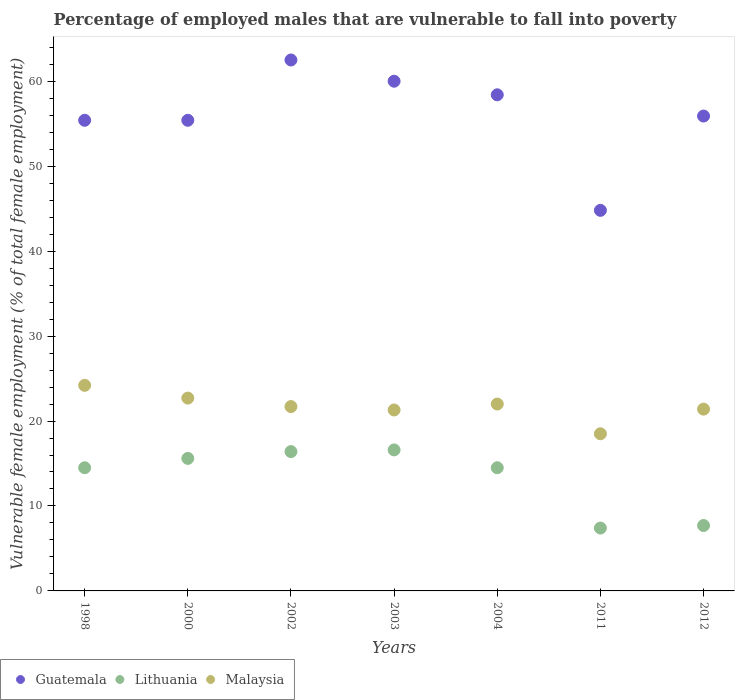Is the number of dotlines equal to the number of legend labels?
Provide a short and direct response. Yes. What is the percentage of employed males who are vulnerable to fall into poverty in Malaysia in 2004?
Ensure brevity in your answer.  22. Across all years, what is the maximum percentage of employed males who are vulnerable to fall into poverty in Guatemala?
Provide a short and direct response. 62.5. Across all years, what is the minimum percentage of employed males who are vulnerable to fall into poverty in Lithuania?
Give a very brief answer. 7.4. In which year was the percentage of employed males who are vulnerable to fall into poverty in Guatemala maximum?
Provide a succinct answer. 2002. What is the total percentage of employed males who are vulnerable to fall into poverty in Malaysia in the graph?
Make the answer very short. 151.8. What is the difference between the percentage of employed males who are vulnerable to fall into poverty in Guatemala in 2000 and that in 2003?
Keep it short and to the point. -4.6. What is the difference between the percentage of employed males who are vulnerable to fall into poverty in Guatemala in 2011 and the percentage of employed males who are vulnerable to fall into poverty in Lithuania in 2003?
Give a very brief answer. 28.2. What is the average percentage of employed males who are vulnerable to fall into poverty in Lithuania per year?
Give a very brief answer. 13.24. In the year 2002, what is the difference between the percentage of employed males who are vulnerable to fall into poverty in Malaysia and percentage of employed males who are vulnerable to fall into poverty in Guatemala?
Keep it short and to the point. -40.8. What is the ratio of the percentage of employed males who are vulnerable to fall into poverty in Malaysia in 2004 to that in 2011?
Your response must be concise. 1.19. Is the percentage of employed males who are vulnerable to fall into poverty in Lithuania in 1998 less than that in 2003?
Offer a very short reply. Yes. What is the difference between the highest and the second highest percentage of employed males who are vulnerable to fall into poverty in Malaysia?
Make the answer very short. 1.5. What is the difference between the highest and the lowest percentage of employed males who are vulnerable to fall into poverty in Malaysia?
Your response must be concise. 5.7. Is the sum of the percentage of employed males who are vulnerable to fall into poverty in Lithuania in 2003 and 2011 greater than the maximum percentage of employed males who are vulnerable to fall into poverty in Guatemala across all years?
Make the answer very short. No. Is the percentage of employed males who are vulnerable to fall into poverty in Lithuania strictly greater than the percentage of employed males who are vulnerable to fall into poverty in Guatemala over the years?
Give a very brief answer. No. How many years are there in the graph?
Provide a succinct answer. 7. Where does the legend appear in the graph?
Your answer should be very brief. Bottom left. How many legend labels are there?
Provide a short and direct response. 3. How are the legend labels stacked?
Your answer should be compact. Horizontal. What is the title of the graph?
Your answer should be very brief. Percentage of employed males that are vulnerable to fall into poverty. What is the label or title of the X-axis?
Offer a very short reply. Years. What is the label or title of the Y-axis?
Make the answer very short. Vulnerable female employment (% of total female employment). What is the Vulnerable female employment (% of total female employment) of Guatemala in 1998?
Provide a short and direct response. 55.4. What is the Vulnerable female employment (% of total female employment) in Malaysia in 1998?
Make the answer very short. 24.2. What is the Vulnerable female employment (% of total female employment) of Guatemala in 2000?
Provide a short and direct response. 55.4. What is the Vulnerable female employment (% of total female employment) in Lithuania in 2000?
Your answer should be compact. 15.6. What is the Vulnerable female employment (% of total female employment) of Malaysia in 2000?
Your answer should be very brief. 22.7. What is the Vulnerable female employment (% of total female employment) of Guatemala in 2002?
Give a very brief answer. 62.5. What is the Vulnerable female employment (% of total female employment) of Lithuania in 2002?
Your response must be concise. 16.4. What is the Vulnerable female employment (% of total female employment) in Malaysia in 2002?
Give a very brief answer. 21.7. What is the Vulnerable female employment (% of total female employment) of Lithuania in 2003?
Provide a succinct answer. 16.6. What is the Vulnerable female employment (% of total female employment) of Malaysia in 2003?
Your answer should be compact. 21.3. What is the Vulnerable female employment (% of total female employment) of Guatemala in 2004?
Keep it short and to the point. 58.4. What is the Vulnerable female employment (% of total female employment) in Malaysia in 2004?
Your answer should be very brief. 22. What is the Vulnerable female employment (% of total female employment) in Guatemala in 2011?
Offer a very short reply. 44.8. What is the Vulnerable female employment (% of total female employment) in Lithuania in 2011?
Ensure brevity in your answer.  7.4. What is the Vulnerable female employment (% of total female employment) of Guatemala in 2012?
Give a very brief answer. 55.9. What is the Vulnerable female employment (% of total female employment) of Lithuania in 2012?
Provide a short and direct response. 7.7. What is the Vulnerable female employment (% of total female employment) in Malaysia in 2012?
Ensure brevity in your answer.  21.4. Across all years, what is the maximum Vulnerable female employment (% of total female employment) in Guatemala?
Offer a very short reply. 62.5. Across all years, what is the maximum Vulnerable female employment (% of total female employment) of Lithuania?
Give a very brief answer. 16.6. Across all years, what is the maximum Vulnerable female employment (% of total female employment) in Malaysia?
Give a very brief answer. 24.2. Across all years, what is the minimum Vulnerable female employment (% of total female employment) of Guatemala?
Offer a very short reply. 44.8. Across all years, what is the minimum Vulnerable female employment (% of total female employment) of Lithuania?
Provide a short and direct response. 7.4. What is the total Vulnerable female employment (% of total female employment) of Guatemala in the graph?
Your answer should be very brief. 392.4. What is the total Vulnerable female employment (% of total female employment) in Lithuania in the graph?
Keep it short and to the point. 92.7. What is the total Vulnerable female employment (% of total female employment) in Malaysia in the graph?
Ensure brevity in your answer.  151.8. What is the difference between the Vulnerable female employment (% of total female employment) in Lithuania in 1998 and that in 2000?
Offer a very short reply. -1.1. What is the difference between the Vulnerable female employment (% of total female employment) of Malaysia in 1998 and that in 2000?
Your response must be concise. 1.5. What is the difference between the Vulnerable female employment (% of total female employment) of Guatemala in 1998 and that in 2002?
Make the answer very short. -7.1. What is the difference between the Vulnerable female employment (% of total female employment) of Lithuania in 1998 and that in 2002?
Provide a short and direct response. -1.9. What is the difference between the Vulnerable female employment (% of total female employment) of Malaysia in 1998 and that in 2002?
Your answer should be very brief. 2.5. What is the difference between the Vulnerable female employment (% of total female employment) of Guatemala in 1998 and that in 2003?
Your response must be concise. -4.6. What is the difference between the Vulnerable female employment (% of total female employment) of Malaysia in 1998 and that in 2003?
Provide a short and direct response. 2.9. What is the difference between the Vulnerable female employment (% of total female employment) of Guatemala in 1998 and that in 2004?
Provide a short and direct response. -3. What is the difference between the Vulnerable female employment (% of total female employment) in Guatemala in 1998 and that in 2011?
Provide a short and direct response. 10.6. What is the difference between the Vulnerable female employment (% of total female employment) in Malaysia in 1998 and that in 2011?
Your answer should be very brief. 5.7. What is the difference between the Vulnerable female employment (% of total female employment) in Guatemala in 2000 and that in 2002?
Ensure brevity in your answer.  -7.1. What is the difference between the Vulnerable female employment (% of total female employment) of Lithuania in 2000 and that in 2002?
Give a very brief answer. -0.8. What is the difference between the Vulnerable female employment (% of total female employment) of Malaysia in 2000 and that in 2002?
Offer a terse response. 1. What is the difference between the Vulnerable female employment (% of total female employment) of Lithuania in 2000 and that in 2003?
Keep it short and to the point. -1. What is the difference between the Vulnerable female employment (% of total female employment) of Guatemala in 2000 and that in 2004?
Provide a succinct answer. -3. What is the difference between the Vulnerable female employment (% of total female employment) of Lithuania in 2000 and that in 2004?
Offer a terse response. 1.1. What is the difference between the Vulnerable female employment (% of total female employment) in Guatemala in 2000 and that in 2012?
Your answer should be very brief. -0.5. What is the difference between the Vulnerable female employment (% of total female employment) in Lithuania in 2000 and that in 2012?
Your answer should be very brief. 7.9. What is the difference between the Vulnerable female employment (% of total female employment) of Malaysia in 2000 and that in 2012?
Ensure brevity in your answer.  1.3. What is the difference between the Vulnerable female employment (% of total female employment) in Guatemala in 2002 and that in 2003?
Keep it short and to the point. 2.5. What is the difference between the Vulnerable female employment (% of total female employment) of Guatemala in 2002 and that in 2004?
Give a very brief answer. 4.1. What is the difference between the Vulnerable female employment (% of total female employment) of Malaysia in 2002 and that in 2004?
Make the answer very short. -0.3. What is the difference between the Vulnerable female employment (% of total female employment) in Guatemala in 2002 and that in 2011?
Ensure brevity in your answer.  17.7. What is the difference between the Vulnerable female employment (% of total female employment) in Guatemala in 2002 and that in 2012?
Your answer should be compact. 6.6. What is the difference between the Vulnerable female employment (% of total female employment) of Lithuania in 2002 and that in 2012?
Give a very brief answer. 8.7. What is the difference between the Vulnerable female employment (% of total female employment) in Lithuania in 2003 and that in 2004?
Offer a very short reply. 2.1. What is the difference between the Vulnerable female employment (% of total female employment) in Malaysia in 2003 and that in 2004?
Make the answer very short. -0.7. What is the difference between the Vulnerable female employment (% of total female employment) of Lithuania in 2003 and that in 2011?
Give a very brief answer. 9.2. What is the difference between the Vulnerable female employment (% of total female employment) in Malaysia in 2003 and that in 2011?
Your response must be concise. 2.8. What is the difference between the Vulnerable female employment (% of total female employment) of Lithuania in 2003 and that in 2012?
Provide a succinct answer. 8.9. What is the difference between the Vulnerable female employment (% of total female employment) of Malaysia in 2003 and that in 2012?
Offer a terse response. -0.1. What is the difference between the Vulnerable female employment (% of total female employment) in Lithuania in 2004 and that in 2011?
Ensure brevity in your answer.  7.1. What is the difference between the Vulnerable female employment (% of total female employment) in Malaysia in 2004 and that in 2011?
Ensure brevity in your answer.  3.5. What is the difference between the Vulnerable female employment (% of total female employment) of Malaysia in 2004 and that in 2012?
Give a very brief answer. 0.6. What is the difference between the Vulnerable female employment (% of total female employment) of Lithuania in 2011 and that in 2012?
Ensure brevity in your answer.  -0.3. What is the difference between the Vulnerable female employment (% of total female employment) of Guatemala in 1998 and the Vulnerable female employment (% of total female employment) of Lithuania in 2000?
Your answer should be very brief. 39.8. What is the difference between the Vulnerable female employment (% of total female employment) of Guatemala in 1998 and the Vulnerable female employment (% of total female employment) of Malaysia in 2000?
Ensure brevity in your answer.  32.7. What is the difference between the Vulnerable female employment (% of total female employment) in Guatemala in 1998 and the Vulnerable female employment (% of total female employment) in Lithuania in 2002?
Offer a terse response. 39. What is the difference between the Vulnerable female employment (% of total female employment) of Guatemala in 1998 and the Vulnerable female employment (% of total female employment) of Malaysia in 2002?
Your answer should be compact. 33.7. What is the difference between the Vulnerable female employment (% of total female employment) of Lithuania in 1998 and the Vulnerable female employment (% of total female employment) of Malaysia in 2002?
Give a very brief answer. -7.2. What is the difference between the Vulnerable female employment (% of total female employment) of Guatemala in 1998 and the Vulnerable female employment (% of total female employment) of Lithuania in 2003?
Give a very brief answer. 38.8. What is the difference between the Vulnerable female employment (% of total female employment) in Guatemala in 1998 and the Vulnerable female employment (% of total female employment) in Malaysia in 2003?
Your response must be concise. 34.1. What is the difference between the Vulnerable female employment (% of total female employment) of Guatemala in 1998 and the Vulnerable female employment (% of total female employment) of Lithuania in 2004?
Provide a succinct answer. 40.9. What is the difference between the Vulnerable female employment (% of total female employment) in Guatemala in 1998 and the Vulnerable female employment (% of total female employment) in Malaysia in 2004?
Provide a short and direct response. 33.4. What is the difference between the Vulnerable female employment (% of total female employment) in Lithuania in 1998 and the Vulnerable female employment (% of total female employment) in Malaysia in 2004?
Provide a short and direct response. -7.5. What is the difference between the Vulnerable female employment (% of total female employment) in Guatemala in 1998 and the Vulnerable female employment (% of total female employment) in Lithuania in 2011?
Make the answer very short. 48. What is the difference between the Vulnerable female employment (% of total female employment) of Guatemala in 1998 and the Vulnerable female employment (% of total female employment) of Malaysia in 2011?
Make the answer very short. 36.9. What is the difference between the Vulnerable female employment (% of total female employment) in Lithuania in 1998 and the Vulnerable female employment (% of total female employment) in Malaysia in 2011?
Give a very brief answer. -4. What is the difference between the Vulnerable female employment (% of total female employment) of Guatemala in 1998 and the Vulnerable female employment (% of total female employment) of Lithuania in 2012?
Give a very brief answer. 47.7. What is the difference between the Vulnerable female employment (% of total female employment) of Guatemala in 1998 and the Vulnerable female employment (% of total female employment) of Malaysia in 2012?
Your answer should be compact. 34. What is the difference between the Vulnerable female employment (% of total female employment) in Guatemala in 2000 and the Vulnerable female employment (% of total female employment) in Lithuania in 2002?
Keep it short and to the point. 39. What is the difference between the Vulnerable female employment (% of total female employment) of Guatemala in 2000 and the Vulnerable female employment (% of total female employment) of Malaysia in 2002?
Your answer should be very brief. 33.7. What is the difference between the Vulnerable female employment (% of total female employment) in Guatemala in 2000 and the Vulnerable female employment (% of total female employment) in Lithuania in 2003?
Offer a terse response. 38.8. What is the difference between the Vulnerable female employment (% of total female employment) of Guatemala in 2000 and the Vulnerable female employment (% of total female employment) of Malaysia in 2003?
Make the answer very short. 34.1. What is the difference between the Vulnerable female employment (% of total female employment) in Guatemala in 2000 and the Vulnerable female employment (% of total female employment) in Lithuania in 2004?
Your answer should be very brief. 40.9. What is the difference between the Vulnerable female employment (% of total female employment) in Guatemala in 2000 and the Vulnerable female employment (% of total female employment) in Malaysia in 2004?
Keep it short and to the point. 33.4. What is the difference between the Vulnerable female employment (% of total female employment) of Lithuania in 2000 and the Vulnerable female employment (% of total female employment) of Malaysia in 2004?
Your response must be concise. -6.4. What is the difference between the Vulnerable female employment (% of total female employment) in Guatemala in 2000 and the Vulnerable female employment (% of total female employment) in Lithuania in 2011?
Ensure brevity in your answer.  48. What is the difference between the Vulnerable female employment (% of total female employment) in Guatemala in 2000 and the Vulnerable female employment (% of total female employment) in Malaysia in 2011?
Make the answer very short. 36.9. What is the difference between the Vulnerable female employment (% of total female employment) in Lithuania in 2000 and the Vulnerable female employment (% of total female employment) in Malaysia in 2011?
Provide a short and direct response. -2.9. What is the difference between the Vulnerable female employment (% of total female employment) in Guatemala in 2000 and the Vulnerable female employment (% of total female employment) in Lithuania in 2012?
Provide a succinct answer. 47.7. What is the difference between the Vulnerable female employment (% of total female employment) in Guatemala in 2002 and the Vulnerable female employment (% of total female employment) in Lithuania in 2003?
Your answer should be compact. 45.9. What is the difference between the Vulnerable female employment (% of total female employment) of Guatemala in 2002 and the Vulnerable female employment (% of total female employment) of Malaysia in 2003?
Provide a short and direct response. 41.2. What is the difference between the Vulnerable female employment (% of total female employment) in Guatemala in 2002 and the Vulnerable female employment (% of total female employment) in Malaysia in 2004?
Ensure brevity in your answer.  40.5. What is the difference between the Vulnerable female employment (% of total female employment) in Guatemala in 2002 and the Vulnerable female employment (% of total female employment) in Lithuania in 2011?
Your answer should be very brief. 55.1. What is the difference between the Vulnerable female employment (% of total female employment) of Guatemala in 2002 and the Vulnerable female employment (% of total female employment) of Malaysia in 2011?
Your answer should be very brief. 44. What is the difference between the Vulnerable female employment (% of total female employment) of Lithuania in 2002 and the Vulnerable female employment (% of total female employment) of Malaysia in 2011?
Give a very brief answer. -2.1. What is the difference between the Vulnerable female employment (% of total female employment) of Guatemala in 2002 and the Vulnerable female employment (% of total female employment) of Lithuania in 2012?
Your answer should be compact. 54.8. What is the difference between the Vulnerable female employment (% of total female employment) in Guatemala in 2002 and the Vulnerable female employment (% of total female employment) in Malaysia in 2012?
Offer a very short reply. 41.1. What is the difference between the Vulnerable female employment (% of total female employment) of Guatemala in 2003 and the Vulnerable female employment (% of total female employment) of Lithuania in 2004?
Your answer should be compact. 45.5. What is the difference between the Vulnerable female employment (% of total female employment) of Guatemala in 2003 and the Vulnerable female employment (% of total female employment) of Malaysia in 2004?
Give a very brief answer. 38. What is the difference between the Vulnerable female employment (% of total female employment) of Lithuania in 2003 and the Vulnerable female employment (% of total female employment) of Malaysia in 2004?
Provide a short and direct response. -5.4. What is the difference between the Vulnerable female employment (% of total female employment) of Guatemala in 2003 and the Vulnerable female employment (% of total female employment) of Lithuania in 2011?
Your answer should be very brief. 52.6. What is the difference between the Vulnerable female employment (% of total female employment) in Guatemala in 2003 and the Vulnerable female employment (% of total female employment) in Malaysia in 2011?
Your answer should be very brief. 41.5. What is the difference between the Vulnerable female employment (% of total female employment) in Lithuania in 2003 and the Vulnerable female employment (% of total female employment) in Malaysia in 2011?
Keep it short and to the point. -1.9. What is the difference between the Vulnerable female employment (% of total female employment) of Guatemala in 2003 and the Vulnerable female employment (% of total female employment) of Lithuania in 2012?
Give a very brief answer. 52.3. What is the difference between the Vulnerable female employment (% of total female employment) in Guatemala in 2003 and the Vulnerable female employment (% of total female employment) in Malaysia in 2012?
Your answer should be compact. 38.6. What is the difference between the Vulnerable female employment (% of total female employment) of Lithuania in 2003 and the Vulnerable female employment (% of total female employment) of Malaysia in 2012?
Provide a short and direct response. -4.8. What is the difference between the Vulnerable female employment (% of total female employment) in Guatemala in 2004 and the Vulnerable female employment (% of total female employment) in Malaysia in 2011?
Offer a very short reply. 39.9. What is the difference between the Vulnerable female employment (% of total female employment) of Lithuania in 2004 and the Vulnerable female employment (% of total female employment) of Malaysia in 2011?
Ensure brevity in your answer.  -4. What is the difference between the Vulnerable female employment (% of total female employment) of Guatemala in 2004 and the Vulnerable female employment (% of total female employment) of Lithuania in 2012?
Your answer should be compact. 50.7. What is the difference between the Vulnerable female employment (% of total female employment) in Guatemala in 2004 and the Vulnerable female employment (% of total female employment) in Malaysia in 2012?
Ensure brevity in your answer.  37. What is the difference between the Vulnerable female employment (% of total female employment) in Lithuania in 2004 and the Vulnerable female employment (% of total female employment) in Malaysia in 2012?
Your answer should be very brief. -6.9. What is the difference between the Vulnerable female employment (% of total female employment) of Guatemala in 2011 and the Vulnerable female employment (% of total female employment) of Lithuania in 2012?
Your answer should be very brief. 37.1. What is the difference between the Vulnerable female employment (% of total female employment) of Guatemala in 2011 and the Vulnerable female employment (% of total female employment) of Malaysia in 2012?
Give a very brief answer. 23.4. What is the difference between the Vulnerable female employment (% of total female employment) of Lithuania in 2011 and the Vulnerable female employment (% of total female employment) of Malaysia in 2012?
Provide a succinct answer. -14. What is the average Vulnerable female employment (% of total female employment) in Guatemala per year?
Offer a terse response. 56.06. What is the average Vulnerable female employment (% of total female employment) of Lithuania per year?
Your answer should be compact. 13.24. What is the average Vulnerable female employment (% of total female employment) in Malaysia per year?
Your answer should be very brief. 21.69. In the year 1998, what is the difference between the Vulnerable female employment (% of total female employment) in Guatemala and Vulnerable female employment (% of total female employment) in Lithuania?
Offer a terse response. 40.9. In the year 1998, what is the difference between the Vulnerable female employment (% of total female employment) in Guatemala and Vulnerable female employment (% of total female employment) in Malaysia?
Make the answer very short. 31.2. In the year 1998, what is the difference between the Vulnerable female employment (% of total female employment) of Lithuania and Vulnerable female employment (% of total female employment) of Malaysia?
Give a very brief answer. -9.7. In the year 2000, what is the difference between the Vulnerable female employment (% of total female employment) of Guatemala and Vulnerable female employment (% of total female employment) of Lithuania?
Your response must be concise. 39.8. In the year 2000, what is the difference between the Vulnerable female employment (% of total female employment) of Guatemala and Vulnerable female employment (% of total female employment) of Malaysia?
Provide a short and direct response. 32.7. In the year 2000, what is the difference between the Vulnerable female employment (% of total female employment) of Lithuania and Vulnerable female employment (% of total female employment) of Malaysia?
Offer a very short reply. -7.1. In the year 2002, what is the difference between the Vulnerable female employment (% of total female employment) of Guatemala and Vulnerable female employment (% of total female employment) of Lithuania?
Keep it short and to the point. 46.1. In the year 2002, what is the difference between the Vulnerable female employment (% of total female employment) in Guatemala and Vulnerable female employment (% of total female employment) in Malaysia?
Provide a succinct answer. 40.8. In the year 2003, what is the difference between the Vulnerable female employment (% of total female employment) of Guatemala and Vulnerable female employment (% of total female employment) of Lithuania?
Offer a very short reply. 43.4. In the year 2003, what is the difference between the Vulnerable female employment (% of total female employment) in Guatemala and Vulnerable female employment (% of total female employment) in Malaysia?
Make the answer very short. 38.7. In the year 2004, what is the difference between the Vulnerable female employment (% of total female employment) of Guatemala and Vulnerable female employment (% of total female employment) of Lithuania?
Offer a terse response. 43.9. In the year 2004, what is the difference between the Vulnerable female employment (% of total female employment) in Guatemala and Vulnerable female employment (% of total female employment) in Malaysia?
Keep it short and to the point. 36.4. In the year 2011, what is the difference between the Vulnerable female employment (% of total female employment) in Guatemala and Vulnerable female employment (% of total female employment) in Lithuania?
Your response must be concise. 37.4. In the year 2011, what is the difference between the Vulnerable female employment (% of total female employment) of Guatemala and Vulnerable female employment (% of total female employment) of Malaysia?
Provide a short and direct response. 26.3. In the year 2011, what is the difference between the Vulnerable female employment (% of total female employment) in Lithuania and Vulnerable female employment (% of total female employment) in Malaysia?
Make the answer very short. -11.1. In the year 2012, what is the difference between the Vulnerable female employment (% of total female employment) of Guatemala and Vulnerable female employment (% of total female employment) of Lithuania?
Your answer should be very brief. 48.2. In the year 2012, what is the difference between the Vulnerable female employment (% of total female employment) of Guatemala and Vulnerable female employment (% of total female employment) of Malaysia?
Keep it short and to the point. 34.5. In the year 2012, what is the difference between the Vulnerable female employment (% of total female employment) of Lithuania and Vulnerable female employment (% of total female employment) of Malaysia?
Keep it short and to the point. -13.7. What is the ratio of the Vulnerable female employment (% of total female employment) in Lithuania in 1998 to that in 2000?
Offer a very short reply. 0.93. What is the ratio of the Vulnerable female employment (% of total female employment) of Malaysia in 1998 to that in 2000?
Give a very brief answer. 1.07. What is the ratio of the Vulnerable female employment (% of total female employment) in Guatemala in 1998 to that in 2002?
Keep it short and to the point. 0.89. What is the ratio of the Vulnerable female employment (% of total female employment) in Lithuania in 1998 to that in 2002?
Provide a short and direct response. 0.88. What is the ratio of the Vulnerable female employment (% of total female employment) of Malaysia in 1998 to that in 2002?
Your answer should be compact. 1.12. What is the ratio of the Vulnerable female employment (% of total female employment) in Guatemala in 1998 to that in 2003?
Keep it short and to the point. 0.92. What is the ratio of the Vulnerable female employment (% of total female employment) of Lithuania in 1998 to that in 2003?
Provide a succinct answer. 0.87. What is the ratio of the Vulnerable female employment (% of total female employment) in Malaysia in 1998 to that in 2003?
Ensure brevity in your answer.  1.14. What is the ratio of the Vulnerable female employment (% of total female employment) of Guatemala in 1998 to that in 2004?
Keep it short and to the point. 0.95. What is the ratio of the Vulnerable female employment (% of total female employment) in Guatemala in 1998 to that in 2011?
Your answer should be very brief. 1.24. What is the ratio of the Vulnerable female employment (% of total female employment) of Lithuania in 1998 to that in 2011?
Your response must be concise. 1.96. What is the ratio of the Vulnerable female employment (% of total female employment) of Malaysia in 1998 to that in 2011?
Your answer should be very brief. 1.31. What is the ratio of the Vulnerable female employment (% of total female employment) of Guatemala in 1998 to that in 2012?
Make the answer very short. 0.99. What is the ratio of the Vulnerable female employment (% of total female employment) in Lithuania in 1998 to that in 2012?
Offer a terse response. 1.88. What is the ratio of the Vulnerable female employment (% of total female employment) of Malaysia in 1998 to that in 2012?
Your answer should be compact. 1.13. What is the ratio of the Vulnerable female employment (% of total female employment) of Guatemala in 2000 to that in 2002?
Your answer should be very brief. 0.89. What is the ratio of the Vulnerable female employment (% of total female employment) in Lithuania in 2000 to that in 2002?
Provide a short and direct response. 0.95. What is the ratio of the Vulnerable female employment (% of total female employment) in Malaysia in 2000 to that in 2002?
Make the answer very short. 1.05. What is the ratio of the Vulnerable female employment (% of total female employment) in Guatemala in 2000 to that in 2003?
Make the answer very short. 0.92. What is the ratio of the Vulnerable female employment (% of total female employment) in Lithuania in 2000 to that in 2003?
Keep it short and to the point. 0.94. What is the ratio of the Vulnerable female employment (% of total female employment) of Malaysia in 2000 to that in 2003?
Your answer should be compact. 1.07. What is the ratio of the Vulnerable female employment (% of total female employment) of Guatemala in 2000 to that in 2004?
Your answer should be compact. 0.95. What is the ratio of the Vulnerable female employment (% of total female employment) in Lithuania in 2000 to that in 2004?
Your response must be concise. 1.08. What is the ratio of the Vulnerable female employment (% of total female employment) in Malaysia in 2000 to that in 2004?
Offer a terse response. 1.03. What is the ratio of the Vulnerable female employment (% of total female employment) in Guatemala in 2000 to that in 2011?
Provide a short and direct response. 1.24. What is the ratio of the Vulnerable female employment (% of total female employment) of Lithuania in 2000 to that in 2011?
Ensure brevity in your answer.  2.11. What is the ratio of the Vulnerable female employment (% of total female employment) in Malaysia in 2000 to that in 2011?
Make the answer very short. 1.23. What is the ratio of the Vulnerable female employment (% of total female employment) of Lithuania in 2000 to that in 2012?
Keep it short and to the point. 2.03. What is the ratio of the Vulnerable female employment (% of total female employment) of Malaysia in 2000 to that in 2012?
Ensure brevity in your answer.  1.06. What is the ratio of the Vulnerable female employment (% of total female employment) of Guatemala in 2002 to that in 2003?
Provide a succinct answer. 1.04. What is the ratio of the Vulnerable female employment (% of total female employment) in Lithuania in 2002 to that in 2003?
Your answer should be compact. 0.99. What is the ratio of the Vulnerable female employment (% of total female employment) in Malaysia in 2002 to that in 2003?
Provide a succinct answer. 1.02. What is the ratio of the Vulnerable female employment (% of total female employment) in Guatemala in 2002 to that in 2004?
Make the answer very short. 1.07. What is the ratio of the Vulnerable female employment (% of total female employment) in Lithuania in 2002 to that in 2004?
Provide a short and direct response. 1.13. What is the ratio of the Vulnerable female employment (% of total female employment) of Malaysia in 2002 to that in 2004?
Make the answer very short. 0.99. What is the ratio of the Vulnerable female employment (% of total female employment) in Guatemala in 2002 to that in 2011?
Your answer should be very brief. 1.4. What is the ratio of the Vulnerable female employment (% of total female employment) in Lithuania in 2002 to that in 2011?
Offer a very short reply. 2.22. What is the ratio of the Vulnerable female employment (% of total female employment) of Malaysia in 2002 to that in 2011?
Make the answer very short. 1.17. What is the ratio of the Vulnerable female employment (% of total female employment) of Guatemala in 2002 to that in 2012?
Provide a succinct answer. 1.12. What is the ratio of the Vulnerable female employment (% of total female employment) of Lithuania in 2002 to that in 2012?
Keep it short and to the point. 2.13. What is the ratio of the Vulnerable female employment (% of total female employment) of Guatemala in 2003 to that in 2004?
Offer a very short reply. 1.03. What is the ratio of the Vulnerable female employment (% of total female employment) of Lithuania in 2003 to that in 2004?
Provide a short and direct response. 1.14. What is the ratio of the Vulnerable female employment (% of total female employment) of Malaysia in 2003 to that in 2004?
Ensure brevity in your answer.  0.97. What is the ratio of the Vulnerable female employment (% of total female employment) in Guatemala in 2003 to that in 2011?
Ensure brevity in your answer.  1.34. What is the ratio of the Vulnerable female employment (% of total female employment) in Lithuania in 2003 to that in 2011?
Keep it short and to the point. 2.24. What is the ratio of the Vulnerable female employment (% of total female employment) in Malaysia in 2003 to that in 2011?
Keep it short and to the point. 1.15. What is the ratio of the Vulnerable female employment (% of total female employment) in Guatemala in 2003 to that in 2012?
Offer a terse response. 1.07. What is the ratio of the Vulnerable female employment (% of total female employment) in Lithuania in 2003 to that in 2012?
Give a very brief answer. 2.16. What is the ratio of the Vulnerable female employment (% of total female employment) in Malaysia in 2003 to that in 2012?
Your response must be concise. 1. What is the ratio of the Vulnerable female employment (% of total female employment) of Guatemala in 2004 to that in 2011?
Provide a short and direct response. 1.3. What is the ratio of the Vulnerable female employment (% of total female employment) of Lithuania in 2004 to that in 2011?
Offer a terse response. 1.96. What is the ratio of the Vulnerable female employment (% of total female employment) in Malaysia in 2004 to that in 2011?
Offer a very short reply. 1.19. What is the ratio of the Vulnerable female employment (% of total female employment) of Guatemala in 2004 to that in 2012?
Give a very brief answer. 1.04. What is the ratio of the Vulnerable female employment (% of total female employment) in Lithuania in 2004 to that in 2012?
Your answer should be compact. 1.88. What is the ratio of the Vulnerable female employment (% of total female employment) of Malaysia in 2004 to that in 2012?
Your response must be concise. 1.03. What is the ratio of the Vulnerable female employment (% of total female employment) of Guatemala in 2011 to that in 2012?
Give a very brief answer. 0.8. What is the ratio of the Vulnerable female employment (% of total female employment) of Malaysia in 2011 to that in 2012?
Give a very brief answer. 0.86. What is the difference between the highest and the lowest Vulnerable female employment (% of total female employment) of Malaysia?
Ensure brevity in your answer.  5.7. 